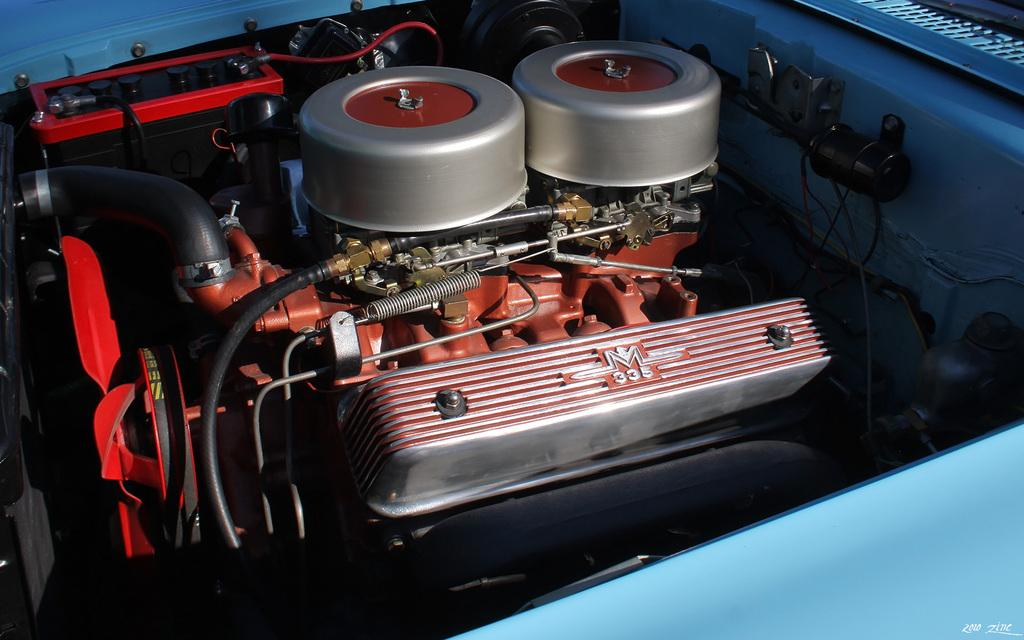What is the main subject of the image? The main subject of the image is a machine. What specific features can be seen on the machine? The machine has wires and pipes attached to it. Are there any other objects attached to the machine? Yes, there are other objects attached to the machine. Can you tell me how many hands the father has in the image? There is no father or hands present in the image; it features a machine with wires and pipes attached to it. What type of hen can be seen interacting with the machine in the image? There is no hen present in the image; it features a machine with wires and pipes attached to it. 